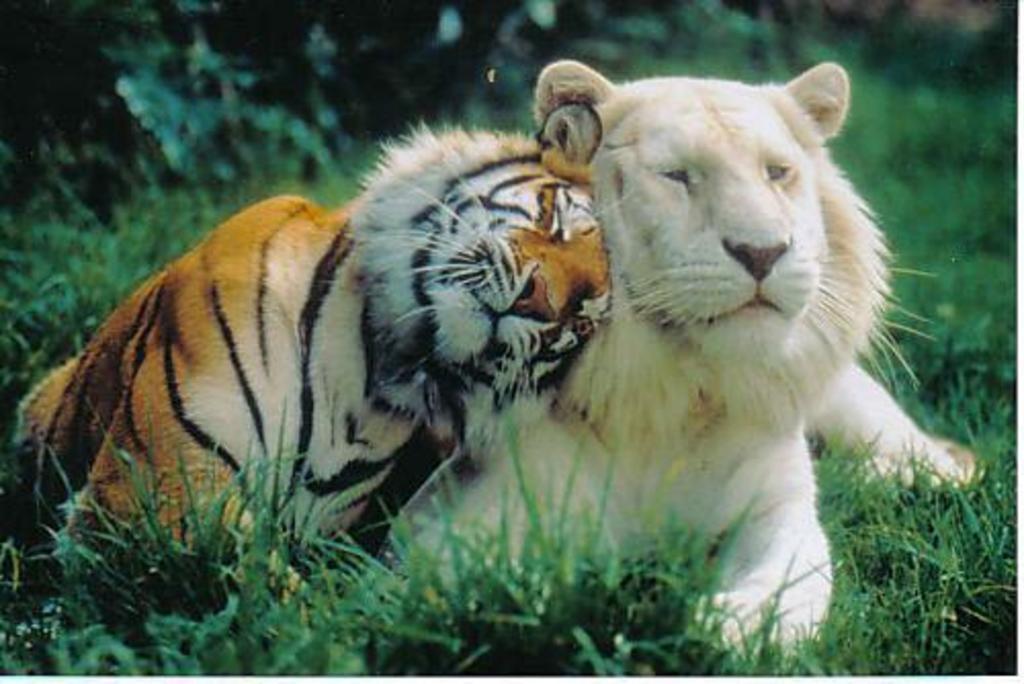Can you describe this image briefly? In this image I can see a tiger which is cream, brown and black in color and another tiger which is white and cream in color are laying on the grass which is green in color. In the background I can see few trees which are green in color. 